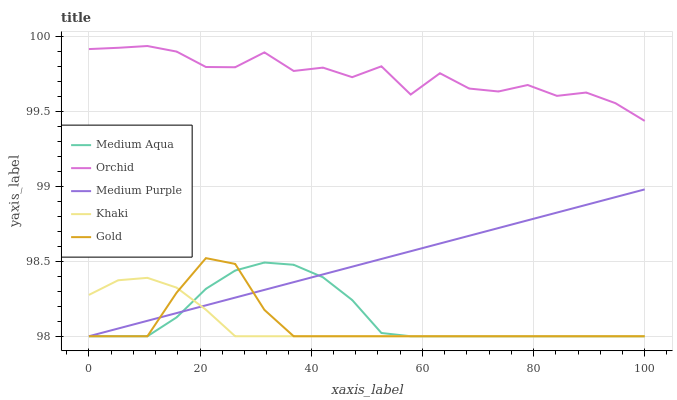Does Medium Aqua have the minimum area under the curve?
Answer yes or no. No. Does Medium Aqua have the maximum area under the curve?
Answer yes or no. No. Is Khaki the smoothest?
Answer yes or no. No. Is Khaki the roughest?
Answer yes or no. No. Does Orchid have the lowest value?
Answer yes or no. No. Does Medium Aqua have the highest value?
Answer yes or no. No. Is Gold less than Orchid?
Answer yes or no. Yes. Is Orchid greater than Khaki?
Answer yes or no. Yes. Does Gold intersect Orchid?
Answer yes or no. No. 